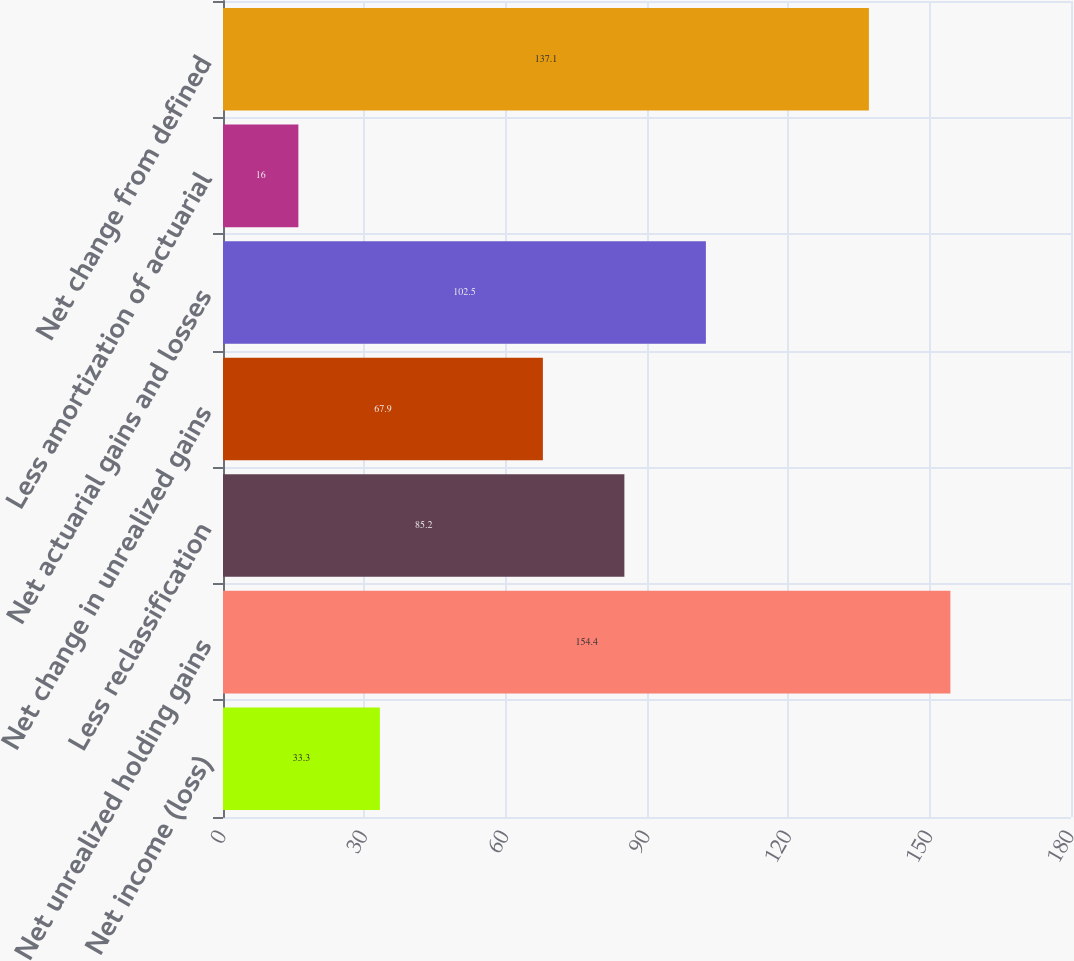Convert chart to OTSL. <chart><loc_0><loc_0><loc_500><loc_500><bar_chart><fcel>Net income (loss)<fcel>Net unrealized holding gains<fcel>Less reclassification<fcel>Net change in unrealized gains<fcel>Net actuarial gains and losses<fcel>Less amortization of actuarial<fcel>Net change from defined<nl><fcel>33.3<fcel>154.4<fcel>85.2<fcel>67.9<fcel>102.5<fcel>16<fcel>137.1<nl></chart> 